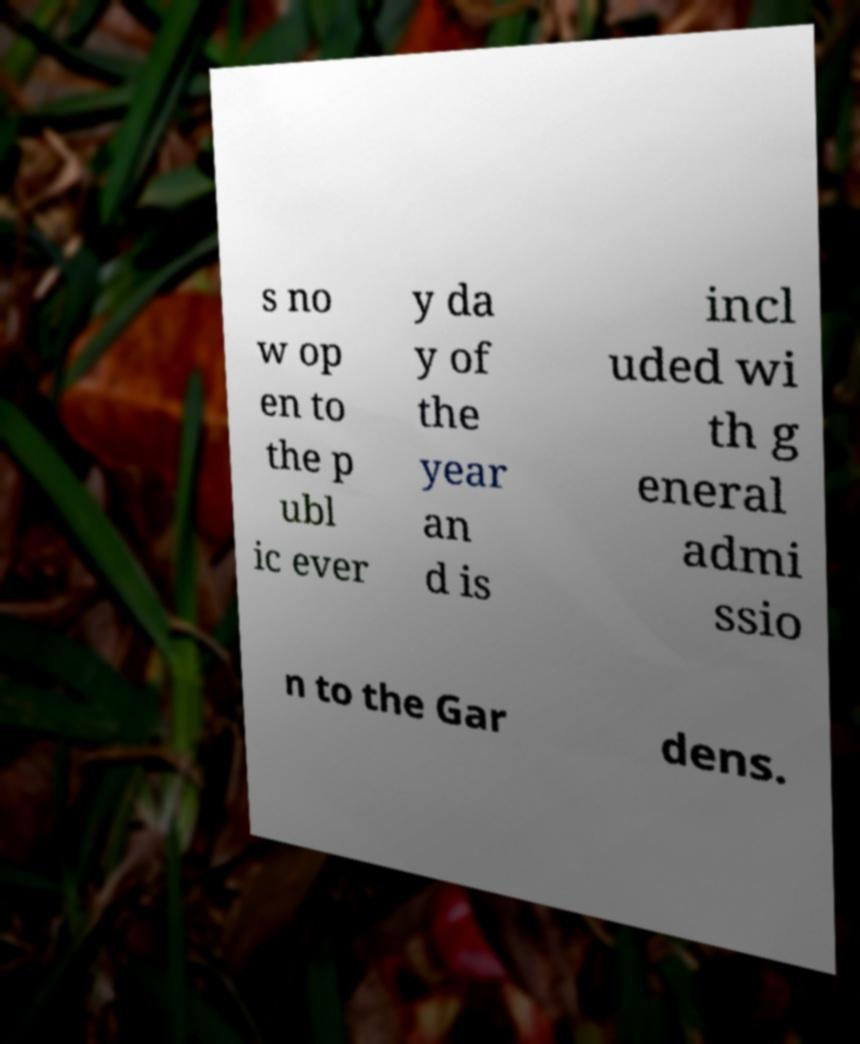Could you assist in decoding the text presented in this image and type it out clearly? s no w op en to the p ubl ic ever y da y of the year an d is incl uded wi th g eneral admi ssio n to the Gar dens. 